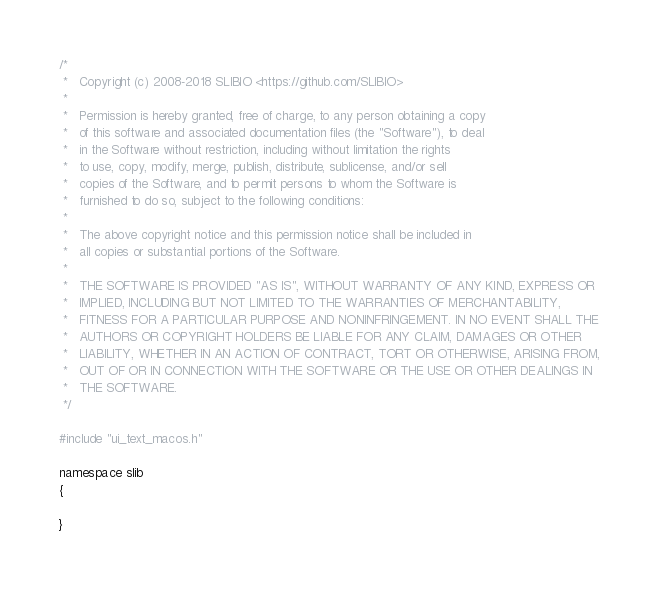Convert code to text. <code><loc_0><loc_0><loc_500><loc_500><_ObjectiveC_>/*
 *   Copyright (c) 2008-2018 SLIBIO <https://github.com/SLIBIO>
 *
 *   Permission is hereby granted, free of charge, to any person obtaining a copy
 *   of this software and associated documentation files (the "Software"), to deal
 *   in the Software without restriction, including without limitation the rights
 *   to use, copy, modify, merge, publish, distribute, sublicense, and/or sell
 *   copies of the Software, and to permit persons to whom the Software is
 *   furnished to do so, subject to the following conditions:
 *
 *   The above copyright notice and this permission notice shall be included in
 *   all copies or substantial portions of the Software.
 *
 *   THE SOFTWARE IS PROVIDED "AS IS", WITHOUT WARRANTY OF ANY KIND, EXPRESS OR
 *   IMPLIED, INCLUDING BUT NOT LIMITED TO THE WARRANTIES OF MERCHANTABILITY,
 *   FITNESS FOR A PARTICULAR PURPOSE AND NONINFRINGEMENT. IN NO EVENT SHALL THE
 *   AUTHORS OR COPYRIGHT HOLDERS BE LIABLE FOR ANY CLAIM, DAMAGES OR OTHER
 *   LIABILITY, WHETHER IN AN ACTION OF CONTRACT, TORT OR OTHERWISE, ARISING FROM,
 *   OUT OF OR IN CONNECTION WITH THE SOFTWARE OR THE USE OR OTHER DEALINGS IN
 *   THE SOFTWARE.
 */

#include "ui_text_macos.h"

namespace slib
{
	
}
</code> 